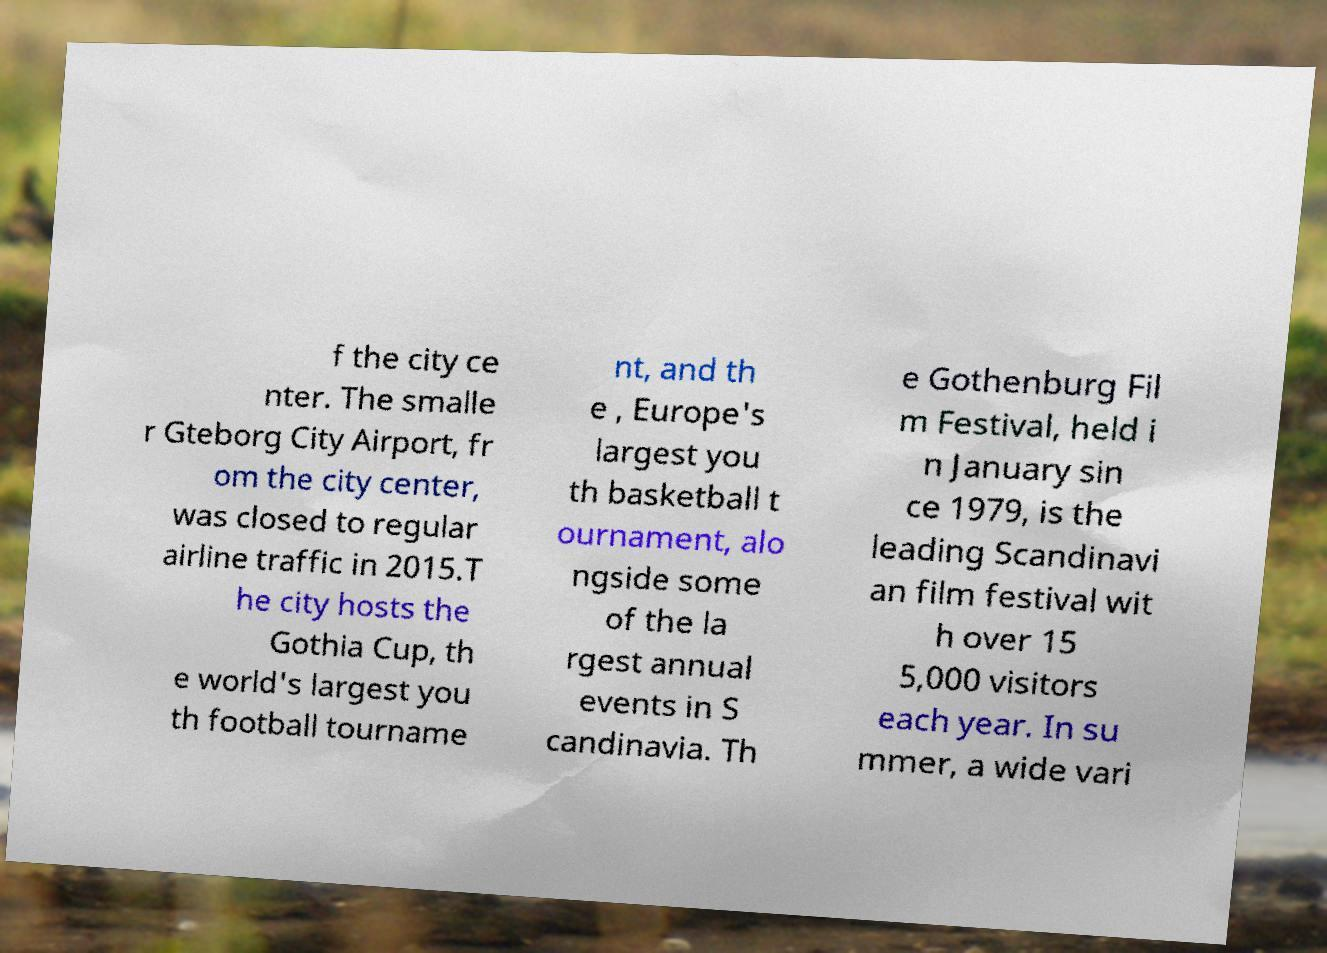Could you assist in decoding the text presented in this image and type it out clearly? f the city ce nter. The smalle r Gteborg City Airport, fr om the city center, was closed to regular airline traffic in 2015.T he city hosts the Gothia Cup, th e world's largest you th football tourname nt, and th e , Europe's largest you th basketball t ournament, alo ngside some of the la rgest annual events in S candinavia. Th e Gothenburg Fil m Festival, held i n January sin ce 1979, is the leading Scandinavi an film festival wit h over 15 5,000 visitors each year. In su mmer, a wide vari 